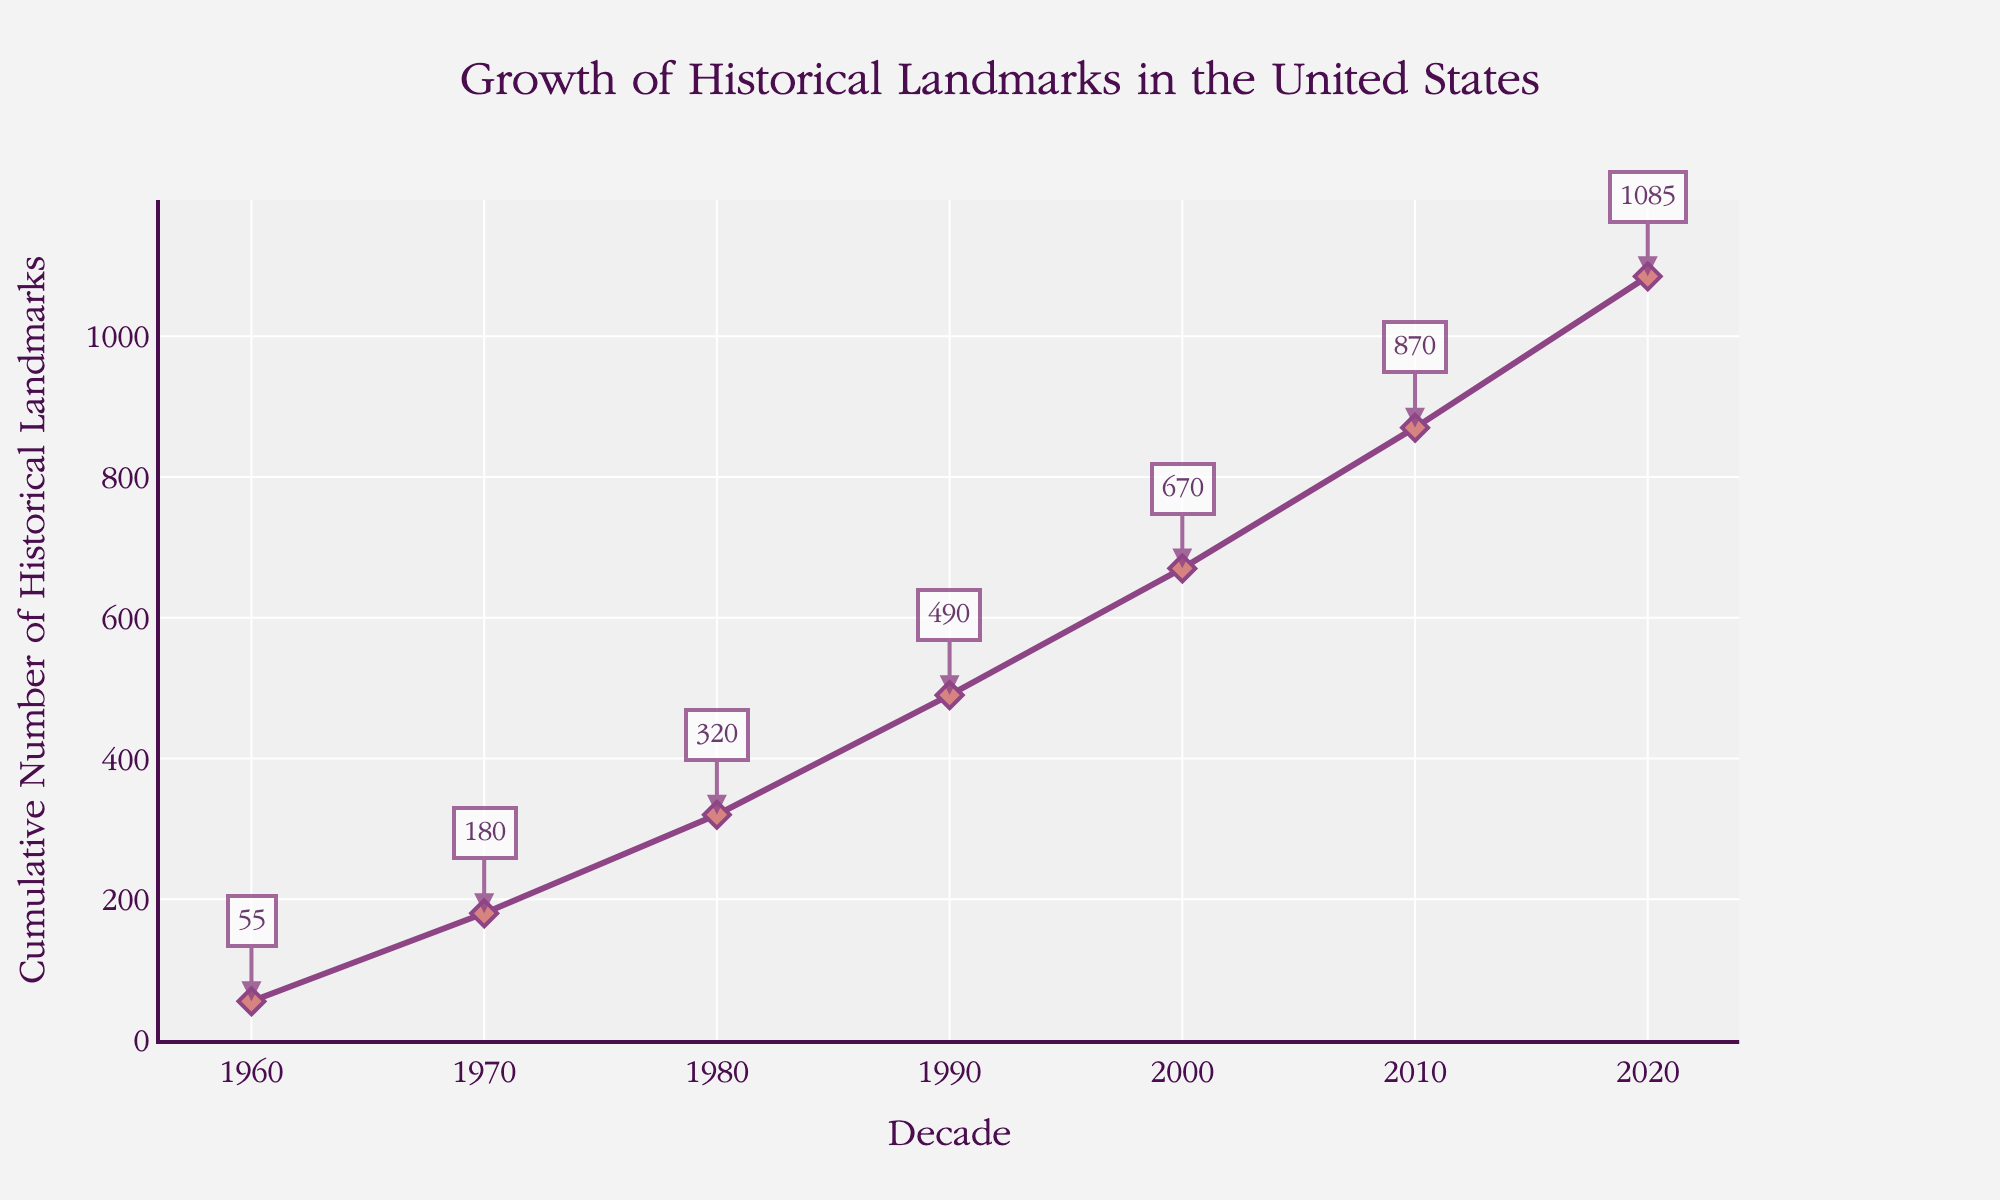what is the title of the plot? The title is usually displayed at the top of the plot, often larger and bolder than other text. In this plot, the title is "Growth of Historical Landmarks in the United States."
Answer: Growth of Historical Landmarks in the United States What is the Cumulative Number of Historical Landmarks in 2000? Locate the data point corresponding to the year 2000 on the x-axis and read the cumulative number of historical landmarks from the y-axis or the annotation label. It is 670.
Answer: 670 How many decades of data are displayed on the x-axis? Count the number of unique decades displayed along the x-axis from 1960 to 2020.
Answer: 7 How much did the cumulative number of historical landmarks increase between 1990 and 2020? Subtract the cumulative number in 1990 from the cumulative number in 2020: 1085 - 490 = 595.
Answer: 595 What pattern do you see in the growth of historical landmarks over the decades? Observe the plot and notice the trend. The number of historical landmarks increases steadily over each decade, with larger increases in each subsequent decade. This suggests a generally accelerating rate of designation.
Answer: Steady increase with accelerating rates What is the average number of historical landmarks designated per decade? Compute the total cumulative number in 2020 (1085) and divide it by the number of decades (7): 1085 / 7 ≈ 155.
Answer: 155 Does any decade show no increase in the number of historical landmarks? Inspect the cumulative figures for each decade and ensure there is no decade where the count remains constant. Every decade shows an increase.
Answer: No Compare the increase in cumulative historical landmarks from 1960 to 1970 versus from 2000 to 2010. Which decade had a shorter increase? Calculate the increase for each decade:
- 1960 to 1970: 180 - 55 = 125
- 2000 to 2010: 870 - 670 = 200
The increase from 1960 to 1970 was shorter.
Answer: 1960 to 1970 What trend can be inferred about the rate of designation of historical landmarks from 1960 to 2020? The plot shows a gradual and increasing trend in the cumulative number of historical landmarks, implying that the rate of landmark designation has been accelerating over the decades.
Answer: Increasing acceleration over time 